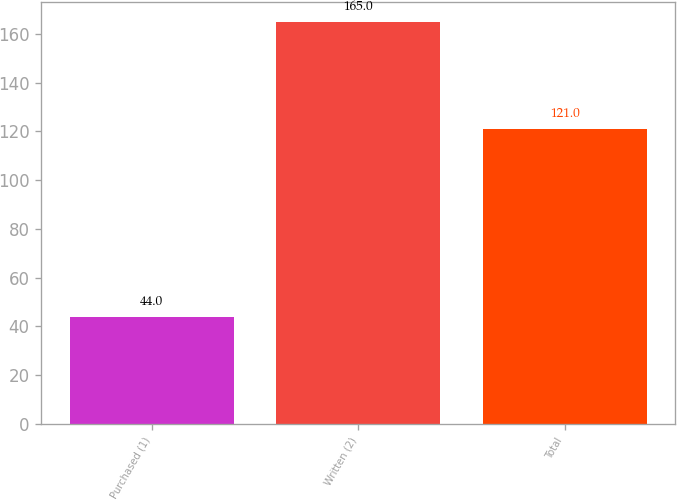Convert chart. <chart><loc_0><loc_0><loc_500><loc_500><bar_chart><fcel>Purchased (1)<fcel>Written (2)<fcel>Total<nl><fcel>44<fcel>165<fcel>121<nl></chart> 